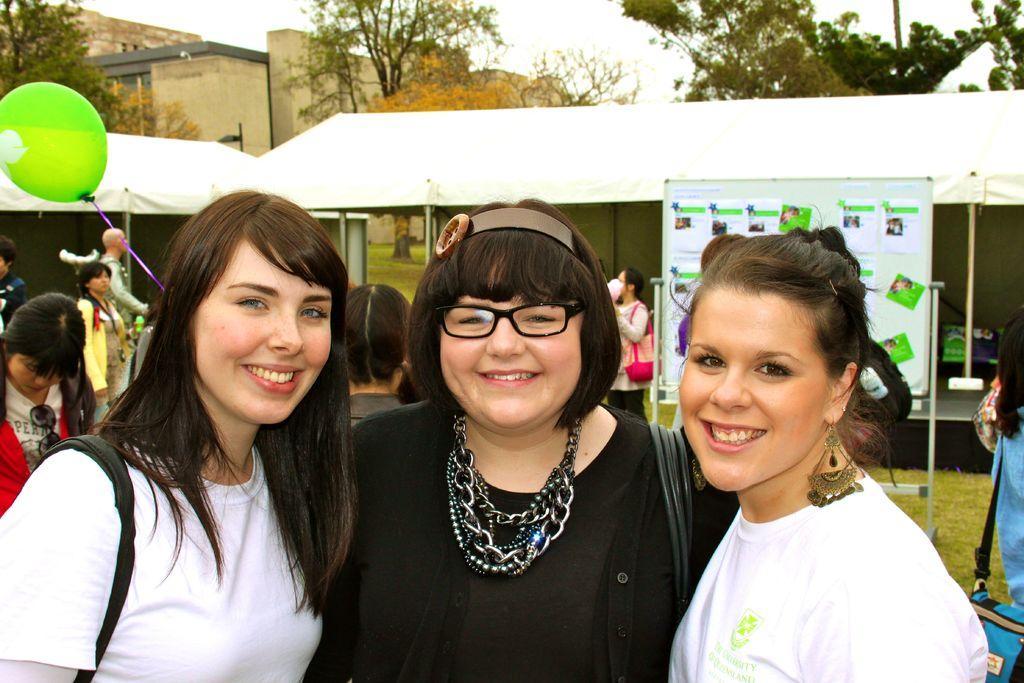In one or two sentences, can you explain what this image depicts? In this image, we can see three women are watching and smiling. Background we can see few people, board, rods, tents, balloon, grass, trees, walls and sky. 